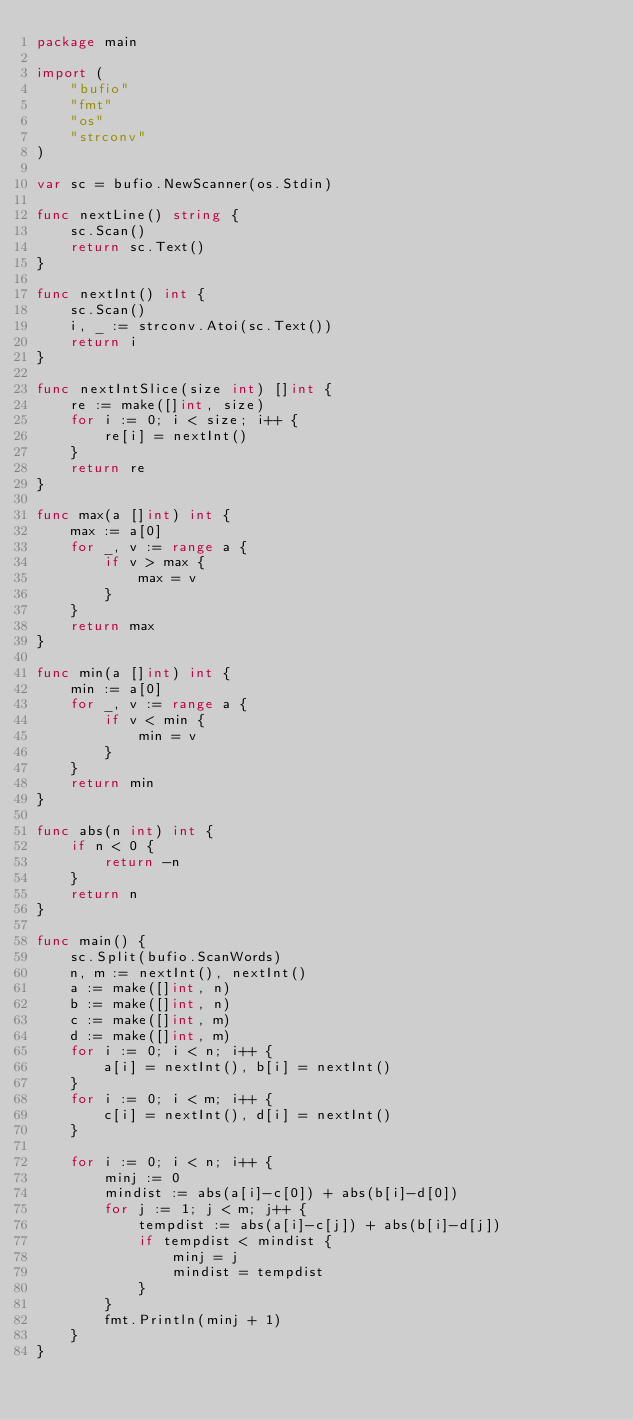<code> <loc_0><loc_0><loc_500><loc_500><_Go_>package main

import (
	"bufio"
	"fmt"
	"os"
	"strconv"
)

var sc = bufio.NewScanner(os.Stdin)

func nextLine() string {
	sc.Scan()
	return sc.Text()
}

func nextInt() int {
	sc.Scan()
	i, _ := strconv.Atoi(sc.Text())
	return i
}

func nextIntSlice(size int) []int {
	re := make([]int, size)
	for i := 0; i < size; i++ {
		re[i] = nextInt()
	}
	return re
}

func max(a []int) int {
	max := a[0]
	for _, v := range a {
		if v > max {
			max = v
		}
	}
	return max
}

func min(a []int) int {
	min := a[0]
	for _, v := range a {
		if v < min {
			min = v
		}
	}
	return min
}

func abs(n int) int {
	if n < 0 {
		return -n
	}
	return n
}

func main() {
	sc.Split(bufio.ScanWords)
	n, m := nextInt(), nextInt()
	a := make([]int, n)
	b := make([]int, n)
	c := make([]int, m)
	d := make([]int, m)
	for i := 0; i < n; i++ {
		a[i] = nextInt(), b[i] = nextInt()
	}
	for i := 0; i < m; i++ {
		c[i] = nextInt(), d[i] = nextInt()
	}

	for i := 0; i < n; i++ {
		minj := 0
		mindist := abs(a[i]-c[0]) + abs(b[i]-d[0])
		for j := 1; j < m; j++ {
			tempdist := abs(a[i]-c[j]) + abs(b[i]-d[j])
			if tempdist < mindist {
				minj = j
				mindist = tempdist
			}
		}
		fmt.Println(minj + 1)
	}
}
</code> 